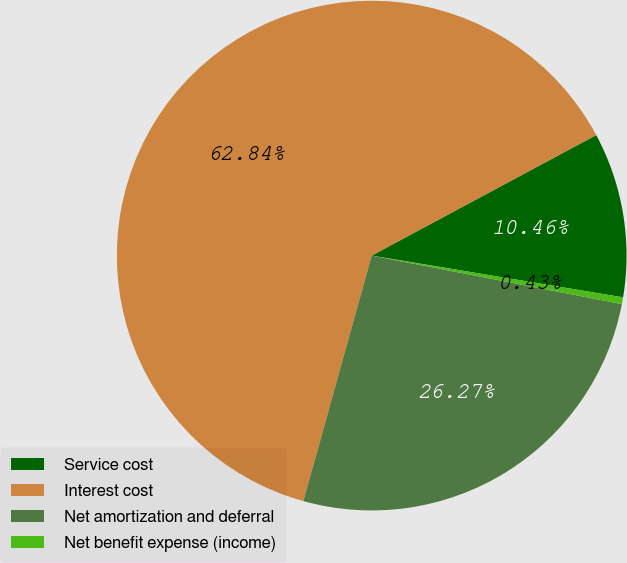<chart> <loc_0><loc_0><loc_500><loc_500><pie_chart><fcel>Service cost<fcel>Interest cost<fcel>Net amortization and deferral<fcel>Net benefit expense (income)<nl><fcel>10.46%<fcel>62.84%<fcel>26.27%<fcel>0.43%<nl></chart> 